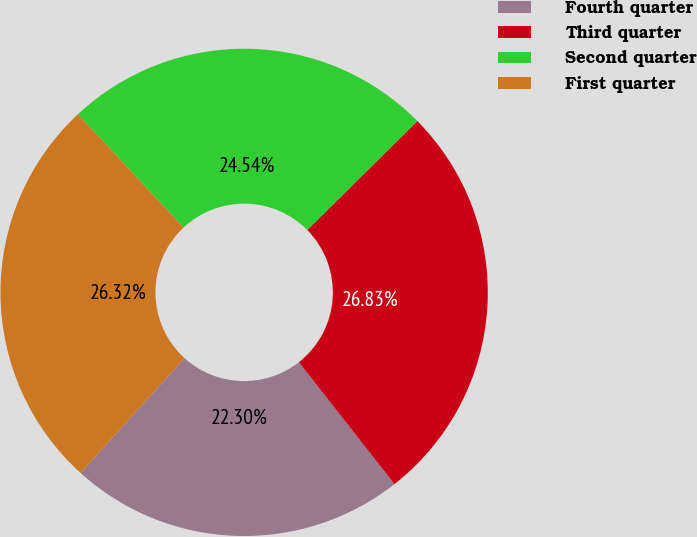Convert chart to OTSL. <chart><loc_0><loc_0><loc_500><loc_500><pie_chart><fcel>Fourth quarter<fcel>Third quarter<fcel>Second quarter<fcel>First quarter<nl><fcel>22.3%<fcel>26.83%<fcel>24.54%<fcel>26.32%<nl></chart> 